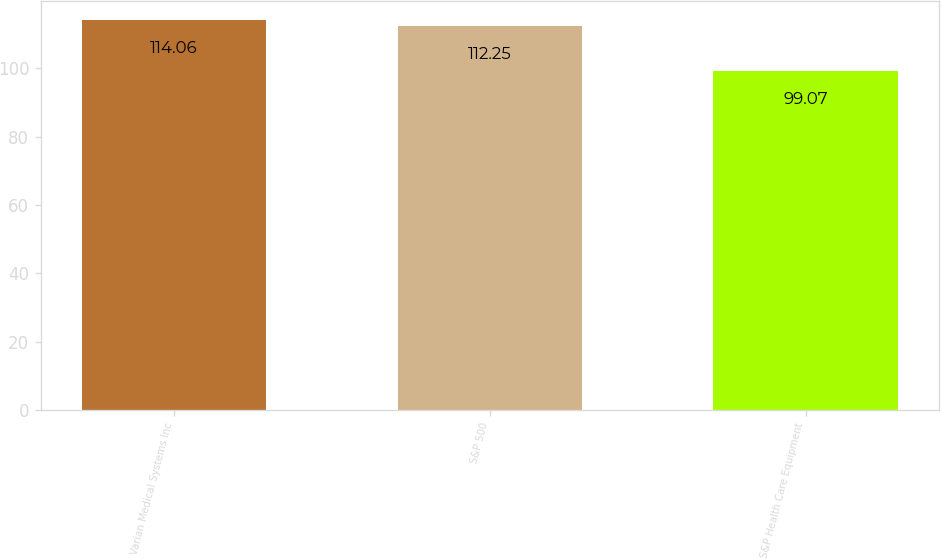Convert chart. <chart><loc_0><loc_0><loc_500><loc_500><bar_chart><fcel>Varian Medical Systems Inc<fcel>S&P 500<fcel>S&P Health Care Equipment<nl><fcel>114.06<fcel>112.25<fcel>99.07<nl></chart> 